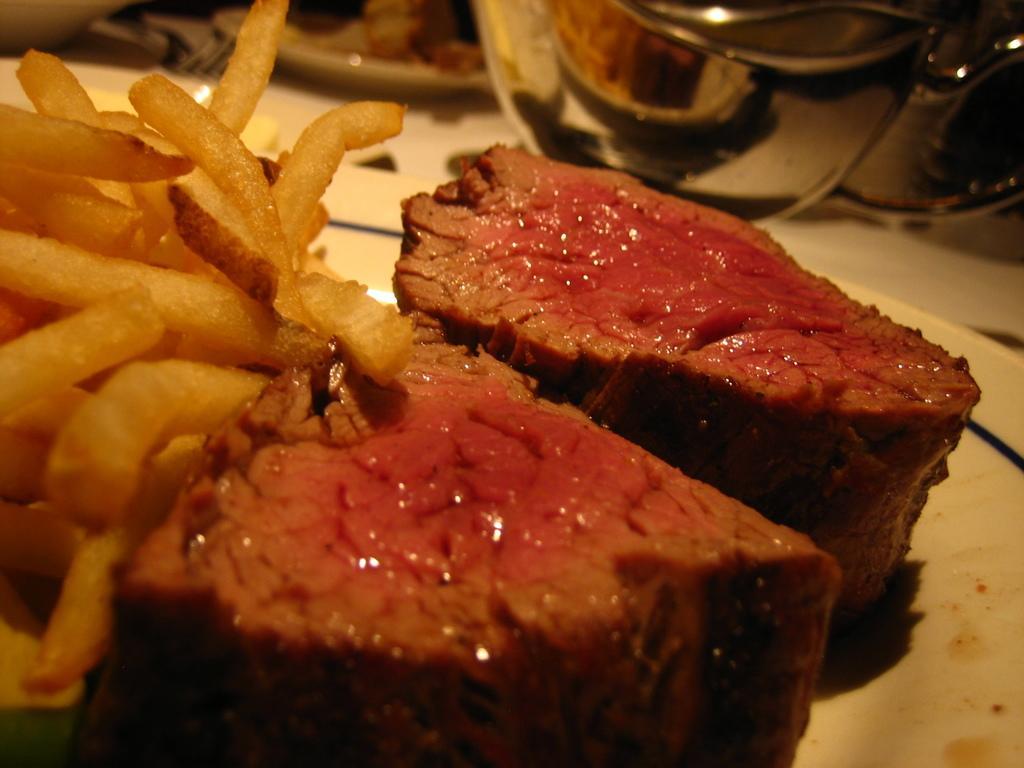Please provide a concise description of this image. This image consists of a plate. It is in white color. On that there are some eatables. Such as french fries and meat. There is a bowl at the top. 